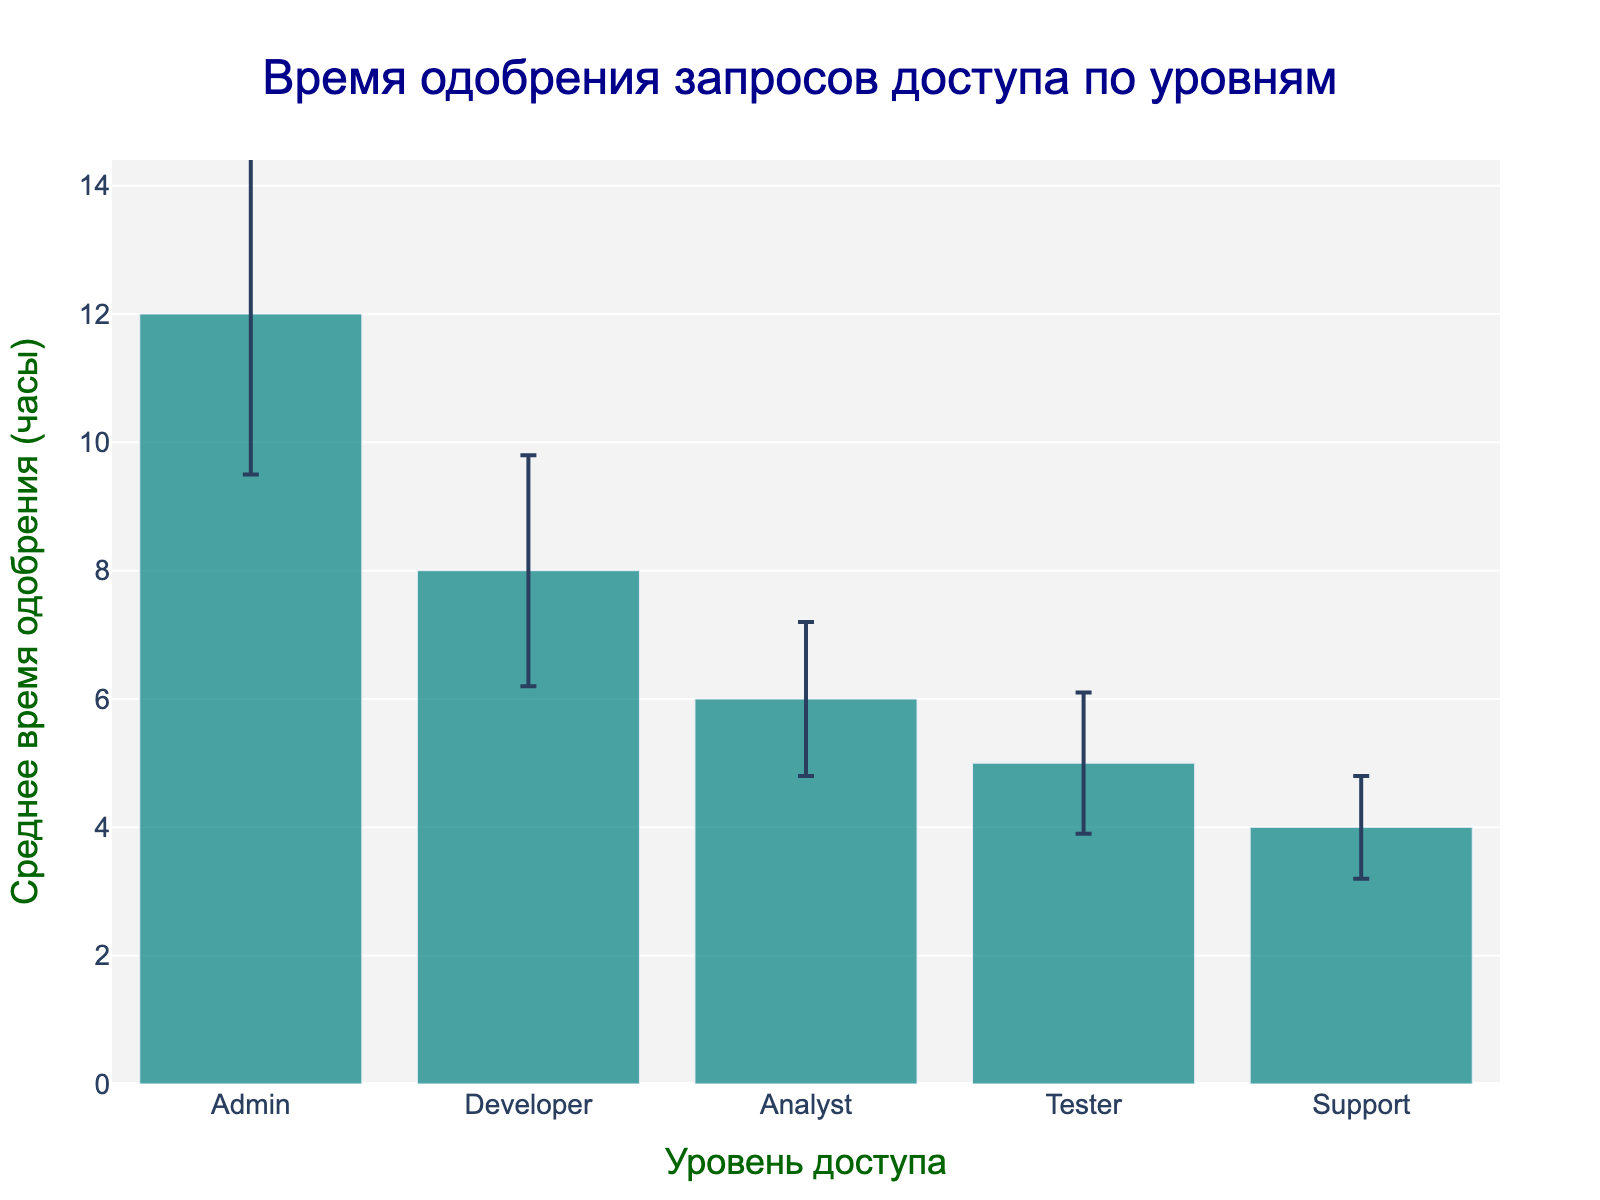what is the title of the plot? The title of the plot is stated at the top of the figure. It is clear and readable.
Answer: Время одобрения запросов доступа по уровням which access level has the highest average approval time? By looking at the height of the bars, the tallest bar represents the access level with the highest average approval time.
Answer: Admin what is the average approval time for the developer access level? Each bar's height represents the average approval time for an access level. The Developer bar height shows 8 hours.
Answer: 8 hours which access level has the smallest standard deviation? The error bars indicate the standard deviation. The smallest error bar corresponds to the Support access level.
Answer: Support what is the difference in average approval time between admin and tester access levels? The bar for Admin shows 12 hours, and the bar for Tester shows 5 hours. Thus, the difference is 12 - 5.
Answer: 7 hours how many access levels are compared in the plot? By counting the number of bars present in the figure, we can identify the number of access levels being compared.
Answer: 5 which access levels have an average approval time within the range of 5 to 10 hours? The bars for Developer, Analyst, and Tester are within the 5 to 10 hours range on the y-axis.
Answer: Developer, Analyst, Tester what is the combined average approval time for support and analyst access levels? The bar for Support shows 4 hours, and the bar for Analyst shows 6 hours. Adding both values gives us the combined approval time.
Answer: 10 hours which access level has an error bar that extends beyond 10 hours? The error bar for Admin extends beyond 10 hours, as seen from the top of the error bar.
Answer: Admin how does the average approval time for support compare to that of admin? The Support bar is much shorter compared to the Admin bar, indicating a lower average approval time.
Answer: Lower 